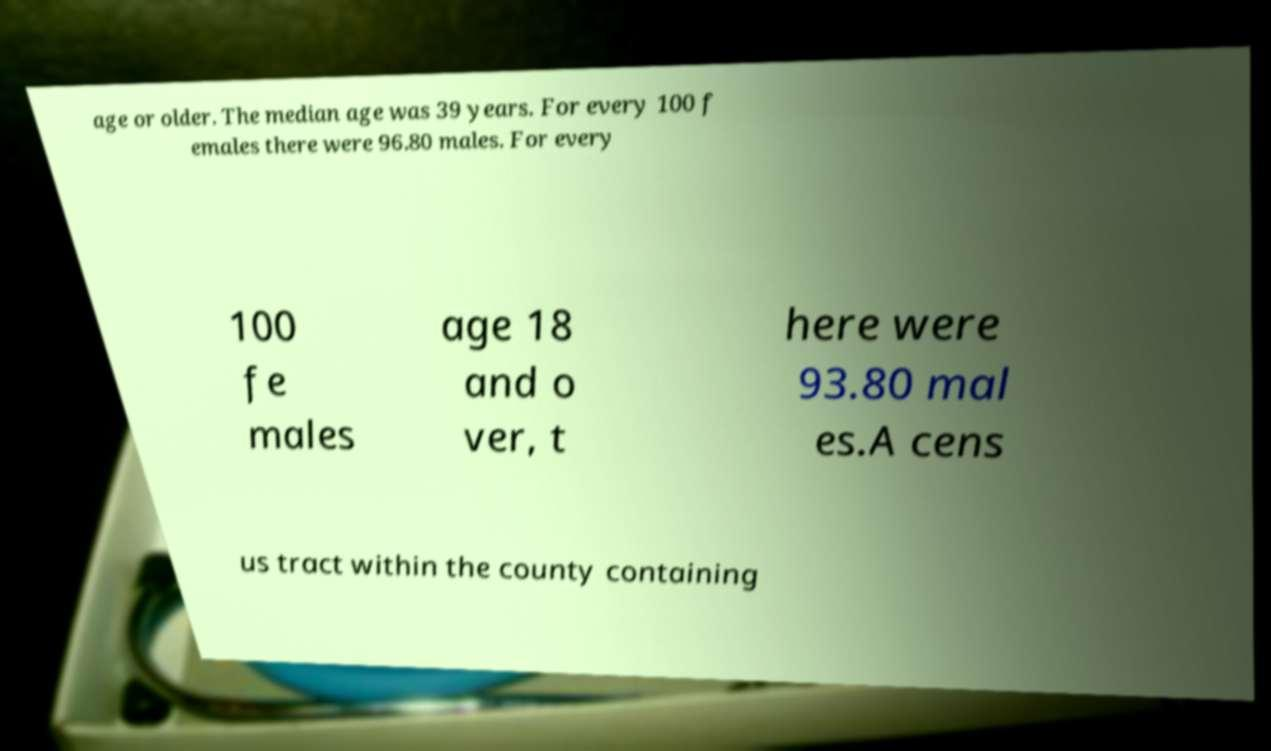For documentation purposes, I need the text within this image transcribed. Could you provide that? age or older. The median age was 39 years. For every 100 f emales there were 96.80 males. For every 100 fe males age 18 and o ver, t here were 93.80 mal es.A cens us tract within the county containing 